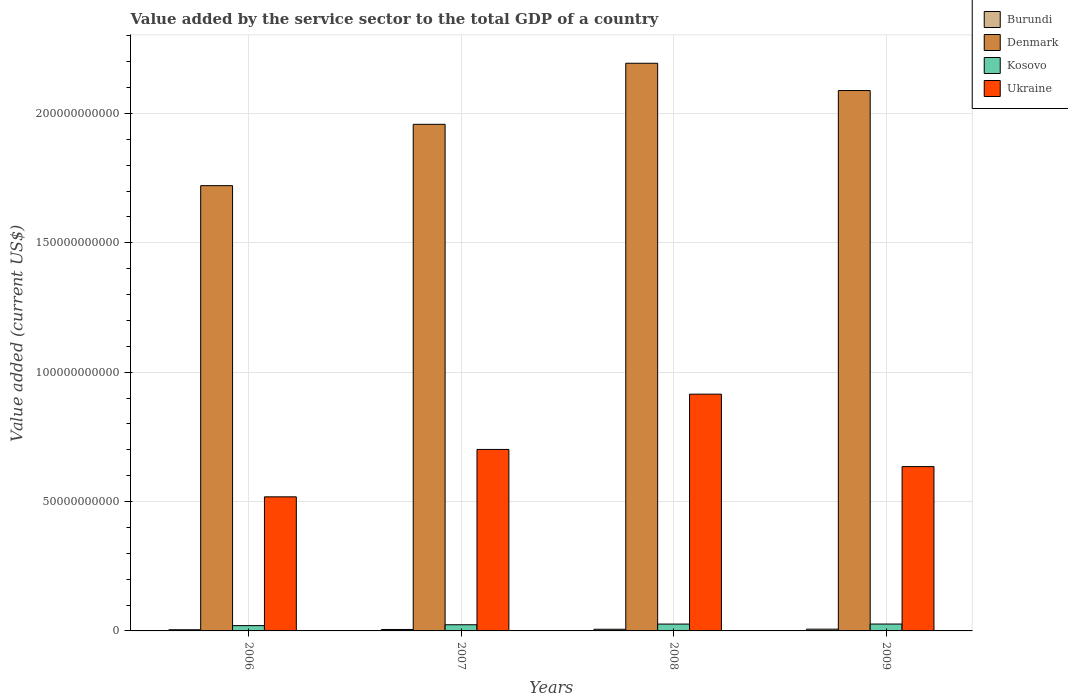Are the number of bars per tick equal to the number of legend labels?
Offer a very short reply. Yes. Are the number of bars on each tick of the X-axis equal?
Give a very brief answer. Yes. What is the value added by the service sector to the total GDP in Burundi in 2009?
Your answer should be compact. 6.80e+08. Across all years, what is the maximum value added by the service sector to the total GDP in Ukraine?
Your answer should be very brief. 9.15e+1. Across all years, what is the minimum value added by the service sector to the total GDP in Burundi?
Offer a very short reply. 4.54e+08. In which year was the value added by the service sector to the total GDP in Kosovo maximum?
Offer a terse response. 2009. What is the total value added by the service sector to the total GDP in Kosovo in the graph?
Provide a short and direct response. 9.74e+09. What is the difference between the value added by the service sector to the total GDP in Ukraine in 2008 and that in 2009?
Provide a succinct answer. 2.80e+1. What is the difference between the value added by the service sector to the total GDP in Denmark in 2007 and the value added by the service sector to the total GDP in Burundi in 2006?
Keep it short and to the point. 1.95e+11. What is the average value added by the service sector to the total GDP in Burundi per year?
Give a very brief answer. 5.83e+08. In the year 2007, what is the difference between the value added by the service sector to the total GDP in Kosovo and value added by the service sector to the total GDP in Ukraine?
Provide a succinct answer. -6.78e+1. What is the ratio of the value added by the service sector to the total GDP in Kosovo in 2007 to that in 2008?
Your answer should be compact. 0.9. Is the value added by the service sector to the total GDP in Ukraine in 2007 less than that in 2008?
Provide a short and direct response. Yes. Is the difference between the value added by the service sector to the total GDP in Kosovo in 2006 and 2009 greater than the difference between the value added by the service sector to the total GDP in Ukraine in 2006 and 2009?
Make the answer very short. Yes. What is the difference between the highest and the second highest value added by the service sector to the total GDP in Burundi?
Offer a terse response. 3.82e+07. What is the difference between the highest and the lowest value added by the service sector to the total GDP in Burundi?
Offer a terse response. 2.26e+08. Is the sum of the value added by the service sector to the total GDP in Kosovo in 2006 and 2009 greater than the maximum value added by the service sector to the total GDP in Ukraine across all years?
Make the answer very short. No. What does the 1st bar from the left in 2009 represents?
Provide a short and direct response. Burundi. Are all the bars in the graph horizontal?
Offer a terse response. No. How many years are there in the graph?
Keep it short and to the point. 4. What is the difference between two consecutive major ticks on the Y-axis?
Give a very brief answer. 5.00e+1. Does the graph contain any zero values?
Ensure brevity in your answer.  No. Does the graph contain grids?
Give a very brief answer. Yes. What is the title of the graph?
Provide a succinct answer. Value added by the service sector to the total GDP of a country. What is the label or title of the Y-axis?
Give a very brief answer. Value added (current US$). What is the Value added (current US$) in Burundi in 2006?
Your answer should be very brief. 4.54e+08. What is the Value added (current US$) in Denmark in 2006?
Provide a succinct answer. 1.72e+11. What is the Value added (current US$) in Kosovo in 2006?
Make the answer very short. 2.05e+09. What is the Value added (current US$) of Ukraine in 2006?
Your answer should be very brief. 5.18e+1. What is the Value added (current US$) of Burundi in 2007?
Ensure brevity in your answer.  5.57e+08. What is the Value added (current US$) in Denmark in 2007?
Make the answer very short. 1.96e+11. What is the Value added (current US$) of Kosovo in 2007?
Offer a terse response. 2.38e+09. What is the Value added (current US$) of Ukraine in 2007?
Provide a succinct answer. 7.01e+1. What is the Value added (current US$) of Burundi in 2008?
Offer a very short reply. 6.42e+08. What is the Value added (current US$) of Denmark in 2008?
Ensure brevity in your answer.  2.19e+11. What is the Value added (current US$) of Kosovo in 2008?
Provide a succinct answer. 2.65e+09. What is the Value added (current US$) in Ukraine in 2008?
Provide a short and direct response. 9.15e+1. What is the Value added (current US$) of Burundi in 2009?
Your response must be concise. 6.80e+08. What is the Value added (current US$) in Denmark in 2009?
Keep it short and to the point. 2.09e+11. What is the Value added (current US$) in Kosovo in 2009?
Your answer should be compact. 2.66e+09. What is the Value added (current US$) of Ukraine in 2009?
Provide a succinct answer. 6.35e+1. Across all years, what is the maximum Value added (current US$) of Burundi?
Make the answer very short. 6.80e+08. Across all years, what is the maximum Value added (current US$) of Denmark?
Offer a very short reply. 2.19e+11. Across all years, what is the maximum Value added (current US$) in Kosovo?
Your answer should be very brief. 2.66e+09. Across all years, what is the maximum Value added (current US$) in Ukraine?
Your answer should be very brief. 9.15e+1. Across all years, what is the minimum Value added (current US$) in Burundi?
Your answer should be very brief. 4.54e+08. Across all years, what is the minimum Value added (current US$) in Denmark?
Your answer should be compact. 1.72e+11. Across all years, what is the minimum Value added (current US$) of Kosovo?
Provide a short and direct response. 2.05e+09. Across all years, what is the minimum Value added (current US$) in Ukraine?
Your response must be concise. 5.18e+1. What is the total Value added (current US$) of Burundi in the graph?
Offer a very short reply. 2.33e+09. What is the total Value added (current US$) in Denmark in the graph?
Keep it short and to the point. 7.96e+11. What is the total Value added (current US$) in Kosovo in the graph?
Your answer should be compact. 9.74e+09. What is the total Value added (current US$) of Ukraine in the graph?
Give a very brief answer. 2.77e+11. What is the difference between the Value added (current US$) in Burundi in 2006 and that in 2007?
Give a very brief answer. -1.02e+08. What is the difference between the Value added (current US$) in Denmark in 2006 and that in 2007?
Offer a terse response. -2.37e+1. What is the difference between the Value added (current US$) of Kosovo in 2006 and that in 2007?
Offer a very short reply. -3.31e+08. What is the difference between the Value added (current US$) in Ukraine in 2006 and that in 2007?
Your response must be concise. -1.83e+1. What is the difference between the Value added (current US$) of Burundi in 2006 and that in 2008?
Make the answer very short. -1.88e+08. What is the difference between the Value added (current US$) in Denmark in 2006 and that in 2008?
Keep it short and to the point. -4.73e+1. What is the difference between the Value added (current US$) in Kosovo in 2006 and that in 2008?
Provide a short and direct response. -5.98e+08. What is the difference between the Value added (current US$) in Ukraine in 2006 and that in 2008?
Your answer should be compact. -3.97e+1. What is the difference between the Value added (current US$) in Burundi in 2006 and that in 2009?
Your answer should be compact. -2.26e+08. What is the difference between the Value added (current US$) of Denmark in 2006 and that in 2009?
Provide a short and direct response. -3.68e+1. What is the difference between the Value added (current US$) of Kosovo in 2006 and that in 2009?
Provide a succinct answer. -6.11e+08. What is the difference between the Value added (current US$) of Ukraine in 2006 and that in 2009?
Ensure brevity in your answer.  -1.17e+1. What is the difference between the Value added (current US$) in Burundi in 2007 and that in 2008?
Give a very brief answer. -8.53e+07. What is the difference between the Value added (current US$) of Denmark in 2007 and that in 2008?
Offer a very short reply. -2.36e+1. What is the difference between the Value added (current US$) of Kosovo in 2007 and that in 2008?
Keep it short and to the point. -2.67e+08. What is the difference between the Value added (current US$) of Ukraine in 2007 and that in 2008?
Keep it short and to the point. -2.14e+1. What is the difference between the Value added (current US$) in Burundi in 2007 and that in 2009?
Offer a very short reply. -1.23e+08. What is the difference between the Value added (current US$) in Denmark in 2007 and that in 2009?
Provide a short and direct response. -1.31e+1. What is the difference between the Value added (current US$) of Kosovo in 2007 and that in 2009?
Provide a succinct answer. -2.80e+08. What is the difference between the Value added (current US$) in Ukraine in 2007 and that in 2009?
Offer a terse response. 6.63e+09. What is the difference between the Value added (current US$) in Burundi in 2008 and that in 2009?
Your response must be concise. -3.82e+07. What is the difference between the Value added (current US$) of Denmark in 2008 and that in 2009?
Provide a succinct answer. 1.05e+1. What is the difference between the Value added (current US$) in Kosovo in 2008 and that in 2009?
Offer a terse response. -1.31e+07. What is the difference between the Value added (current US$) of Ukraine in 2008 and that in 2009?
Make the answer very short. 2.80e+1. What is the difference between the Value added (current US$) of Burundi in 2006 and the Value added (current US$) of Denmark in 2007?
Your response must be concise. -1.95e+11. What is the difference between the Value added (current US$) of Burundi in 2006 and the Value added (current US$) of Kosovo in 2007?
Offer a terse response. -1.93e+09. What is the difference between the Value added (current US$) of Burundi in 2006 and the Value added (current US$) of Ukraine in 2007?
Provide a short and direct response. -6.97e+1. What is the difference between the Value added (current US$) of Denmark in 2006 and the Value added (current US$) of Kosovo in 2007?
Keep it short and to the point. 1.70e+11. What is the difference between the Value added (current US$) in Denmark in 2006 and the Value added (current US$) in Ukraine in 2007?
Offer a very short reply. 1.02e+11. What is the difference between the Value added (current US$) in Kosovo in 2006 and the Value added (current US$) in Ukraine in 2007?
Your answer should be very brief. -6.81e+1. What is the difference between the Value added (current US$) in Burundi in 2006 and the Value added (current US$) in Denmark in 2008?
Provide a succinct answer. -2.19e+11. What is the difference between the Value added (current US$) in Burundi in 2006 and the Value added (current US$) in Kosovo in 2008?
Ensure brevity in your answer.  -2.19e+09. What is the difference between the Value added (current US$) of Burundi in 2006 and the Value added (current US$) of Ukraine in 2008?
Offer a terse response. -9.10e+1. What is the difference between the Value added (current US$) of Denmark in 2006 and the Value added (current US$) of Kosovo in 2008?
Your answer should be very brief. 1.69e+11. What is the difference between the Value added (current US$) of Denmark in 2006 and the Value added (current US$) of Ukraine in 2008?
Give a very brief answer. 8.06e+1. What is the difference between the Value added (current US$) of Kosovo in 2006 and the Value added (current US$) of Ukraine in 2008?
Provide a short and direct response. -8.95e+1. What is the difference between the Value added (current US$) of Burundi in 2006 and the Value added (current US$) of Denmark in 2009?
Offer a very short reply. -2.08e+11. What is the difference between the Value added (current US$) of Burundi in 2006 and the Value added (current US$) of Kosovo in 2009?
Provide a succinct answer. -2.21e+09. What is the difference between the Value added (current US$) in Burundi in 2006 and the Value added (current US$) in Ukraine in 2009?
Ensure brevity in your answer.  -6.31e+1. What is the difference between the Value added (current US$) in Denmark in 2006 and the Value added (current US$) in Kosovo in 2009?
Offer a terse response. 1.69e+11. What is the difference between the Value added (current US$) of Denmark in 2006 and the Value added (current US$) of Ukraine in 2009?
Ensure brevity in your answer.  1.09e+11. What is the difference between the Value added (current US$) in Kosovo in 2006 and the Value added (current US$) in Ukraine in 2009?
Offer a very short reply. -6.15e+1. What is the difference between the Value added (current US$) of Burundi in 2007 and the Value added (current US$) of Denmark in 2008?
Ensure brevity in your answer.  -2.19e+11. What is the difference between the Value added (current US$) of Burundi in 2007 and the Value added (current US$) of Kosovo in 2008?
Offer a terse response. -2.09e+09. What is the difference between the Value added (current US$) in Burundi in 2007 and the Value added (current US$) in Ukraine in 2008?
Ensure brevity in your answer.  -9.09e+1. What is the difference between the Value added (current US$) in Denmark in 2007 and the Value added (current US$) in Kosovo in 2008?
Ensure brevity in your answer.  1.93e+11. What is the difference between the Value added (current US$) in Denmark in 2007 and the Value added (current US$) in Ukraine in 2008?
Your answer should be very brief. 1.04e+11. What is the difference between the Value added (current US$) in Kosovo in 2007 and the Value added (current US$) in Ukraine in 2008?
Make the answer very short. -8.91e+1. What is the difference between the Value added (current US$) of Burundi in 2007 and the Value added (current US$) of Denmark in 2009?
Give a very brief answer. -2.08e+11. What is the difference between the Value added (current US$) of Burundi in 2007 and the Value added (current US$) of Kosovo in 2009?
Provide a succinct answer. -2.10e+09. What is the difference between the Value added (current US$) in Burundi in 2007 and the Value added (current US$) in Ukraine in 2009?
Your answer should be very brief. -6.30e+1. What is the difference between the Value added (current US$) in Denmark in 2007 and the Value added (current US$) in Kosovo in 2009?
Keep it short and to the point. 1.93e+11. What is the difference between the Value added (current US$) of Denmark in 2007 and the Value added (current US$) of Ukraine in 2009?
Provide a succinct answer. 1.32e+11. What is the difference between the Value added (current US$) of Kosovo in 2007 and the Value added (current US$) of Ukraine in 2009?
Your answer should be very brief. -6.11e+1. What is the difference between the Value added (current US$) in Burundi in 2008 and the Value added (current US$) in Denmark in 2009?
Keep it short and to the point. -2.08e+11. What is the difference between the Value added (current US$) in Burundi in 2008 and the Value added (current US$) in Kosovo in 2009?
Offer a very short reply. -2.02e+09. What is the difference between the Value added (current US$) of Burundi in 2008 and the Value added (current US$) of Ukraine in 2009?
Keep it short and to the point. -6.29e+1. What is the difference between the Value added (current US$) of Denmark in 2008 and the Value added (current US$) of Kosovo in 2009?
Keep it short and to the point. 2.17e+11. What is the difference between the Value added (current US$) of Denmark in 2008 and the Value added (current US$) of Ukraine in 2009?
Keep it short and to the point. 1.56e+11. What is the difference between the Value added (current US$) of Kosovo in 2008 and the Value added (current US$) of Ukraine in 2009?
Give a very brief answer. -6.09e+1. What is the average Value added (current US$) in Burundi per year?
Provide a short and direct response. 5.83e+08. What is the average Value added (current US$) of Denmark per year?
Keep it short and to the point. 1.99e+11. What is the average Value added (current US$) of Kosovo per year?
Offer a very short reply. 2.43e+09. What is the average Value added (current US$) in Ukraine per year?
Give a very brief answer. 6.92e+1. In the year 2006, what is the difference between the Value added (current US$) in Burundi and Value added (current US$) in Denmark?
Your answer should be very brief. -1.72e+11. In the year 2006, what is the difference between the Value added (current US$) of Burundi and Value added (current US$) of Kosovo?
Offer a very short reply. -1.59e+09. In the year 2006, what is the difference between the Value added (current US$) in Burundi and Value added (current US$) in Ukraine?
Offer a terse response. -5.14e+1. In the year 2006, what is the difference between the Value added (current US$) of Denmark and Value added (current US$) of Kosovo?
Offer a very short reply. 1.70e+11. In the year 2006, what is the difference between the Value added (current US$) in Denmark and Value added (current US$) in Ukraine?
Offer a very short reply. 1.20e+11. In the year 2006, what is the difference between the Value added (current US$) in Kosovo and Value added (current US$) in Ukraine?
Ensure brevity in your answer.  -4.98e+1. In the year 2007, what is the difference between the Value added (current US$) of Burundi and Value added (current US$) of Denmark?
Offer a terse response. -1.95e+11. In the year 2007, what is the difference between the Value added (current US$) of Burundi and Value added (current US$) of Kosovo?
Your answer should be very brief. -1.82e+09. In the year 2007, what is the difference between the Value added (current US$) of Burundi and Value added (current US$) of Ukraine?
Your answer should be compact. -6.96e+1. In the year 2007, what is the difference between the Value added (current US$) of Denmark and Value added (current US$) of Kosovo?
Make the answer very short. 1.93e+11. In the year 2007, what is the difference between the Value added (current US$) in Denmark and Value added (current US$) in Ukraine?
Your response must be concise. 1.26e+11. In the year 2007, what is the difference between the Value added (current US$) in Kosovo and Value added (current US$) in Ukraine?
Your answer should be compact. -6.78e+1. In the year 2008, what is the difference between the Value added (current US$) in Burundi and Value added (current US$) in Denmark?
Give a very brief answer. -2.19e+11. In the year 2008, what is the difference between the Value added (current US$) in Burundi and Value added (current US$) in Kosovo?
Offer a terse response. -2.00e+09. In the year 2008, what is the difference between the Value added (current US$) in Burundi and Value added (current US$) in Ukraine?
Keep it short and to the point. -9.09e+1. In the year 2008, what is the difference between the Value added (current US$) in Denmark and Value added (current US$) in Kosovo?
Give a very brief answer. 2.17e+11. In the year 2008, what is the difference between the Value added (current US$) in Denmark and Value added (current US$) in Ukraine?
Your response must be concise. 1.28e+11. In the year 2008, what is the difference between the Value added (current US$) in Kosovo and Value added (current US$) in Ukraine?
Your answer should be very brief. -8.89e+1. In the year 2009, what is the difference between the Value added (current US$) of Burundi and Value added (current US$) of Denmark?
Keep it short and to the point. -2.08e+11. In the year 2009, what is the difference between the Value added (current US$) in Burundi and Value added (current US$) in Kosovo?
Make the answer very short. -1.98e+09. In the year 2009, what is the difference between the Value added (current US$) in Burundi and Value added (current US$) in Ukraine?
Your response must be concise. -6.28e+1. In the year 2009, what is the difference between the Value added (current US$) of Denmark and Value added (current US$) of Kosovo?
Provide a short and direct response. 2.06e+11. In the year 2009, what is the difference between the Value added (current US$) of Denmark and Value added (current US$) of Ukraine?
Make the answer very short. 1.45e+11. In the year 2009, what is the difference between the Value added (current US$) in Kosovo and Value added (current US$) in Ukraine?
Your answer should be very brief. -6.09e+1. What is the ratio of the Value added (current US$) in Burundi in 2006 to that in 2007?
Your response must be concise. 0.82. What is the ratio of the Value added (current US$) in Denmark in 2006 to that in 2007?
Keep it short and to the point. 0.88. What is the ratio of the Value added (current US$) in Kosovo in 2006 to that in 2007?
Give a very brief answer. 0.86. What is the ratio of the Value added (current US$) of Ukraine in 2006 to that in 2007?
Keep it short and to the point. 0.74. What is the ratio of the Value added (current US$) of Burundi in 2006 to that in 2008?
Keep it short and to the point. 0.71. What is the ratio of the Value added (current US$) of Denmark in 2006 to that in 2008?
Ensure brevity in your answer.  0.78. What is the ratio of the Value added (current US$) of Kosovo in 2006 to that in 2008?
Offer a very short reply. 0.77. What is the ratio of the Value added (current US$) of Ukraine in 2006 to that in 2008?
Keep it short and to the point. 0.57. What is the ratio of the Value added (current US$) in Burundi in 2006 to that in 2009?
Offer a terse response. 0.67. What is the ratio of the Value added (current US$) of Denmark in 2006 to that in 2009?
Provide a short and direct response. 0.82. What is the ratio of the Value added (current US$) in Kosovo in 2006 to that in 2009?
Ensure brevity in your answer.  0.77. What is the ratio of the Value added (current US$) of Ukraine in 2006 to that in 2009?
Offer a very short reply. 0.82. What is the ratio of the Value added (current US$) of Burundi in 2007 to that in 2008?
Your answer should be compact. 0.87. What is the ratio of the Value added (current US$) in Denmark in 2007 to that in 2008?
Keep it short and to the point. 0.89. What is the ratio of the Value added (current US$) of Kosovo in 2007 to that in 2008?
Ensure brevity in your answer.  0.9. What is the ratio of the Value added (current US$) in Ukraine in 2007 to that in 2008?
Your answer should be very brief. 0.77. What is the ratio of the Value added (current US$) in Burundi in 2007 to that in 2009?
Your response must be concise. 0.82. What is the ratio of the Value added (current US$) of Denmark in 2007 to that in 2009?
Your answer should be compact. 0.94. What is the ratio of the Value added (current US$) of Kosovo in 2007 to that in 2009?
Make the answer very short. 0.89. What is the ratio of the Value added (current US$) of Ukraine in 2007 to that in 2009?
Offer a terse response. 1.1. What is the ratio of the Value added (current US$) of Burundi in 2008 to that in 2009?
Provide a succinct answer. 0.94. What is the ratio of the Value added (current US$) in Denmark in 2008 to that in 2009?
Your response must be concise. 1.05. What is the ratio of the Value added (current US$) of Ukraine in 2008 to that in 2009?
Your answer should be very brief. 1.44. What is the difference between the highest and the second highest Value added (current US$) in Burundi?
Offer a very short reply. 3.82e+07. What is the difference between the highest and the second highest Value added (current US$) in Denmark?
Give a very brief answer. 1.05e+1. What is the difference between the highest and the second highest Value added (current US$) of Kosovo?
Your answer should be compact. 1.31e+07. What is the difference between the highest and the second highest Value added (current US$) in Ukraine?
Provide a short and direct response. 2.14e+1. What is the difference between the highest and the lowest Value added (current US$) of Burundi?
Offer a very short reply. 2.26e+08. What is the difference between the highest and the lowest Value added (current US$) of Denmark?
Your answer should be compact. 4.73e+1. What is the difference between the highest and the lowest Value added (current US$) in Kosovo?
Provide a succinct answer. 6.11e+08. What is the difference between the highest and the lowest Value added (current US$) in Ukraine?
Offer a terse response. 3.97e+1. 